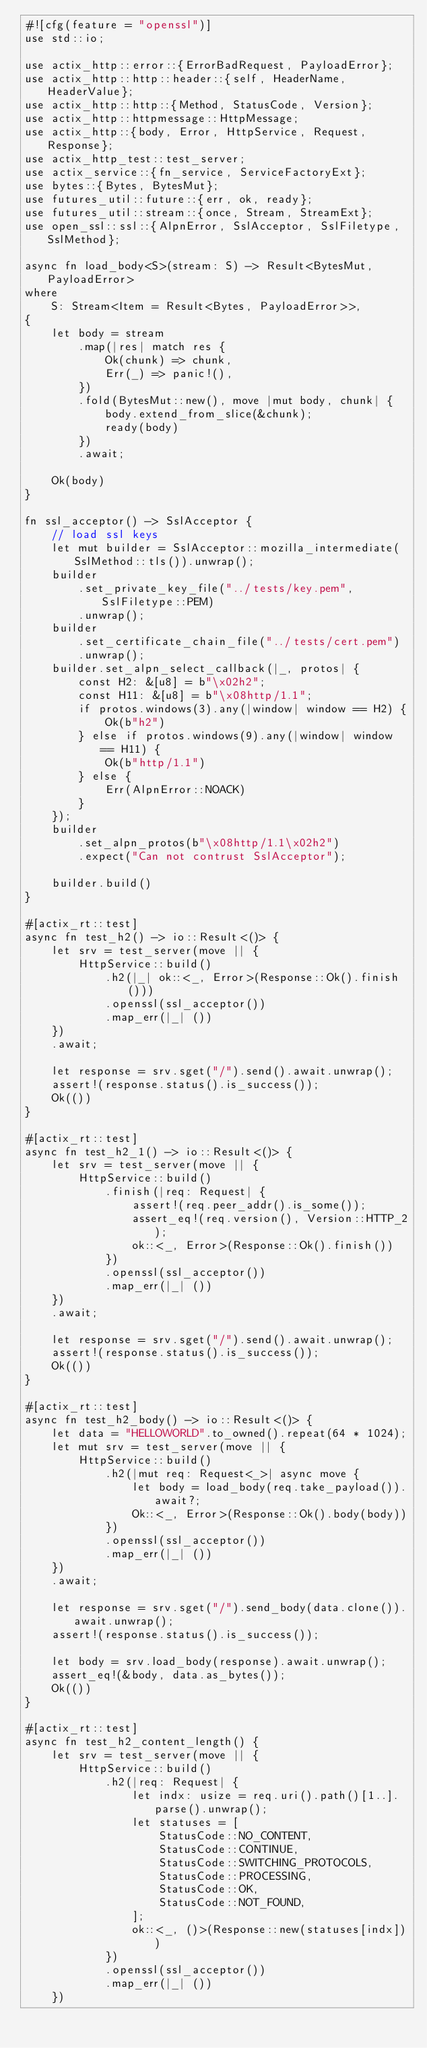<code> <loc_0><loc_0><loc_500><loc_500><_Rust_>#![cfg(feature = "openssl")]
use std::io;

use actix_http::error::{ErrorBadRequest, PayloadError};
use actix_http::http::header::{self, HeaderName, HeaderValue};
use actix_http::http::{Method, StatusCode, Version};
use actix_http::httpmessage::HttpMessage;
use actix_http::{body, Error, HttpService, Request, Response};
use actix_http_test::test_server;
use actix_service::{fn_service, ServiceFactoryExt};
use bytes::{Bytes, BytesMut};
use futures_util::future::{err, ok, ready};
use futures_util::stream::{once, Stream, StreamExt};
use open_ssl::ssl::{AlpnError, SslAcceptor, SslFiletype, SslMethod};

async fn load_body<S>(stream: S) -> Result<BytesMut, PayloadError>
where
    S: Stream<Item = Result<Bytes, PayloadError>>,
{
    let body = stream
        .map(|res| match res {
            Ok(chunk) => chunk,
            Err(_) => panic!(),
        })
        .fold(BytesMut::new(), move |mut body, chunk| {
            body.extend_from_slice(&chunk);
            ready(body)
        })
        .await;

    Ok(body)
}

fn ssl_acceptor() -> SslAcceptor {
    // load ssl keys
    let mut builder = SslAcceptor::mozilla_intermediate(SslMethod::tls()).unwrap();
    builder
        .set_private_key_file("../tests/key.pem", SslFiletype::PEM)
        .unwrap();
    builder
        .set_certificate_chain_file("../tests/cert.pem")
        .unwrap();
    builder.set_alpn_select_callback(|_, protos| {
        const H2: &[u8] = b"\x02h2";
        const H11: &[u8] = b"\x08http/1.1";
        if protos.windows(3).any(|window| window == H2) {
            Ok(b"h2")
        } else if protos.windows(9).any(|window| window == H11) {
            Ok(b"http/1.1")
        } else {
            Err(AlpnError::NOACK)
        }
    });
    builder
        .set_alpn_protos(b"\x08http/1.1\x02h2")
        .expect("Can not contrust SslAcceptor");

    builder.build()
}

#[actix_rt::test]
async fn test_h2() -> io::Result<()> {
    let srv = test_server(move || {
        HttpService::build()
            .h2(|_| ok::<_, Error>(Response::Ok().finish()))
            .openssl(ssl_acceptor())
            .map_err(|_| ())
    })
    .await;

    let response = srv.sget("/").send().await.unwrap();
    assert!(response.status().is_success());
    Ok(())
}

#[actix_rt::test]
async fn test_h2_1() -> io::Result<()> {
    let srv = test_server(move || {
        HttpService::build()
            .finish(|req: Request| {
                assert!(req.peer_addr().is_some());
                assert_eq!(req.version(), Version::HTTP_2);
                ok::<_, Error>(Response::Ok().finish())
            })
            .openssl(ssl_acceptor())
            .map_err(|_| ())
    })
    .await;

    let response = srv.sget("/").send().await.unwrap();
    assert!(response.status().is_success());
    Ok(())
}

#[actix_rt::test]
async fn test_h2_body() -> io::Result<()> {
    let data = "HELLOWORLD".to_owned().repeat(64 * 1024);
    let mut srv = test_server(move || {
        HttpService::build()
            .h2(|mut req: Request<_>| async move {
                let body = load_body(req.take_payload()).await?;
                Ok::<_, Error>(Response::Ok().body(body))
            })
            .openssl(ssl_acceptor())
            .map_err(|_| ())
    })
    .await;

    let response = srv.sget("/").send_body(data.clone()).await.unwrap();
    assert!(response.status().is_success());

    let body = srv.load_body(response).await.unwrap();
    assert_eq!(&body, data.as_bytes());
    Ok(())
}

#[actix_rt::test]
async fn test_h2_content_length() {
    let srv = test_server(move || {
        HttpService::build()
            .h2(|req: Request| {
                let indx: usize = req.uri().path()[1..].parse().unwrap();
                let statuses = [
                    StatusCode::NO_CONTENT,
                    StatusCode::CONTINUE,
                    StatusCode::SWITCHING_PROTOCOLS,
                    StatusCode::PROCESSING,
                    StatusCode::OK,
                    StatusCode::NOT_FOUND,
                ];
                ok::<_, ()>(Response::new(statuses[indx]))
            })
            .openssl(ssl_acceptor())
            .map_err(|_| ())
    })</code> 